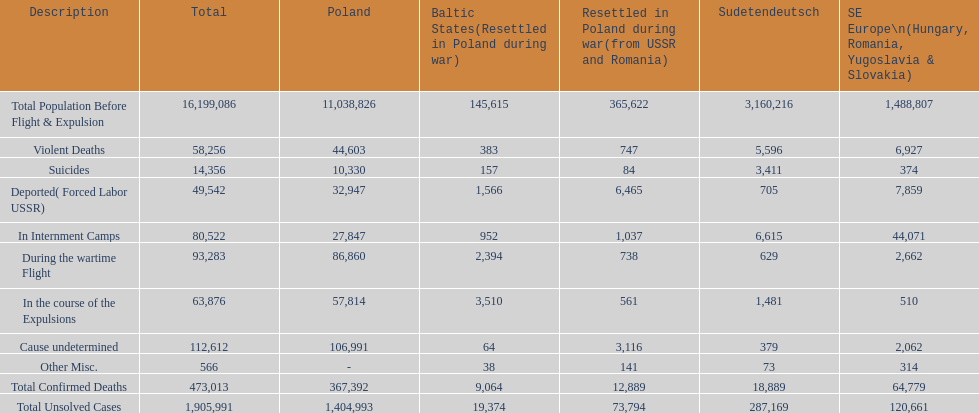Were there any places without violent fatalities? No. 